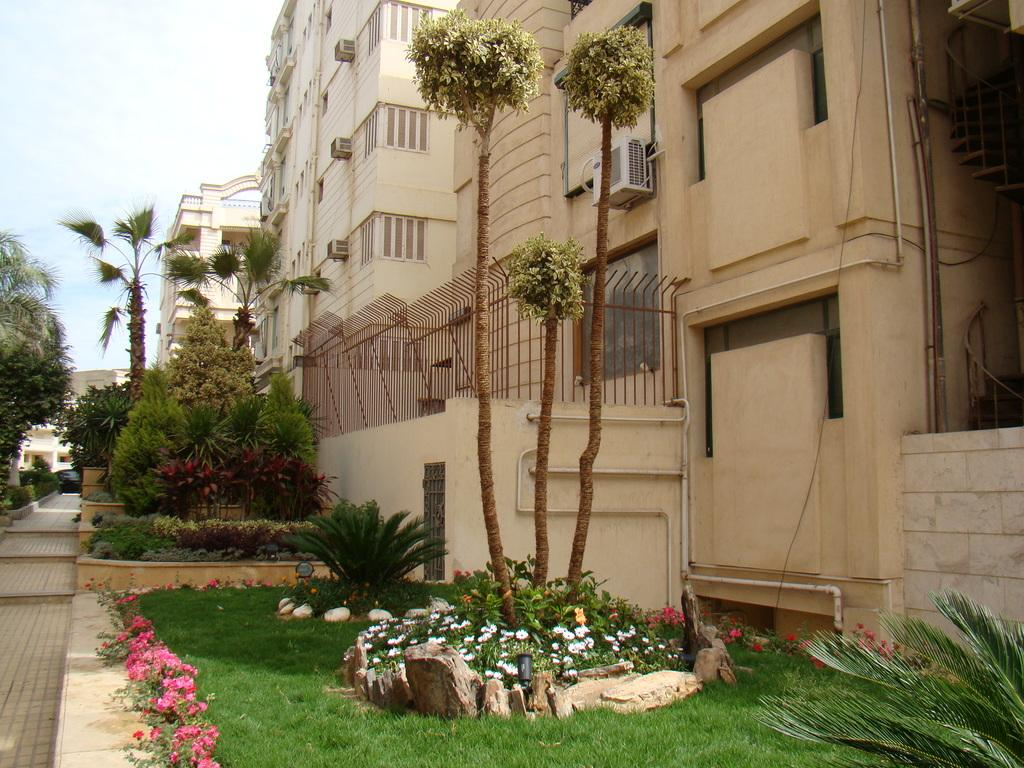What type of structures can be seen in the image? There are buildings in the image. What natural elements are present in the image? There are trees, grass, and flower plants in the image. What type of path is visible in the image? There is a footpath in the image. What is visible in the sky in the image? The sky is visible in the image. Are there any architectural features in the image? Yes, there are stairs and a fence in the image. Where is the vase placed in the image? There is no vase present in the image. What type of work is being done by the branch in the image? There is no branch or work being done by a branch in the image. 